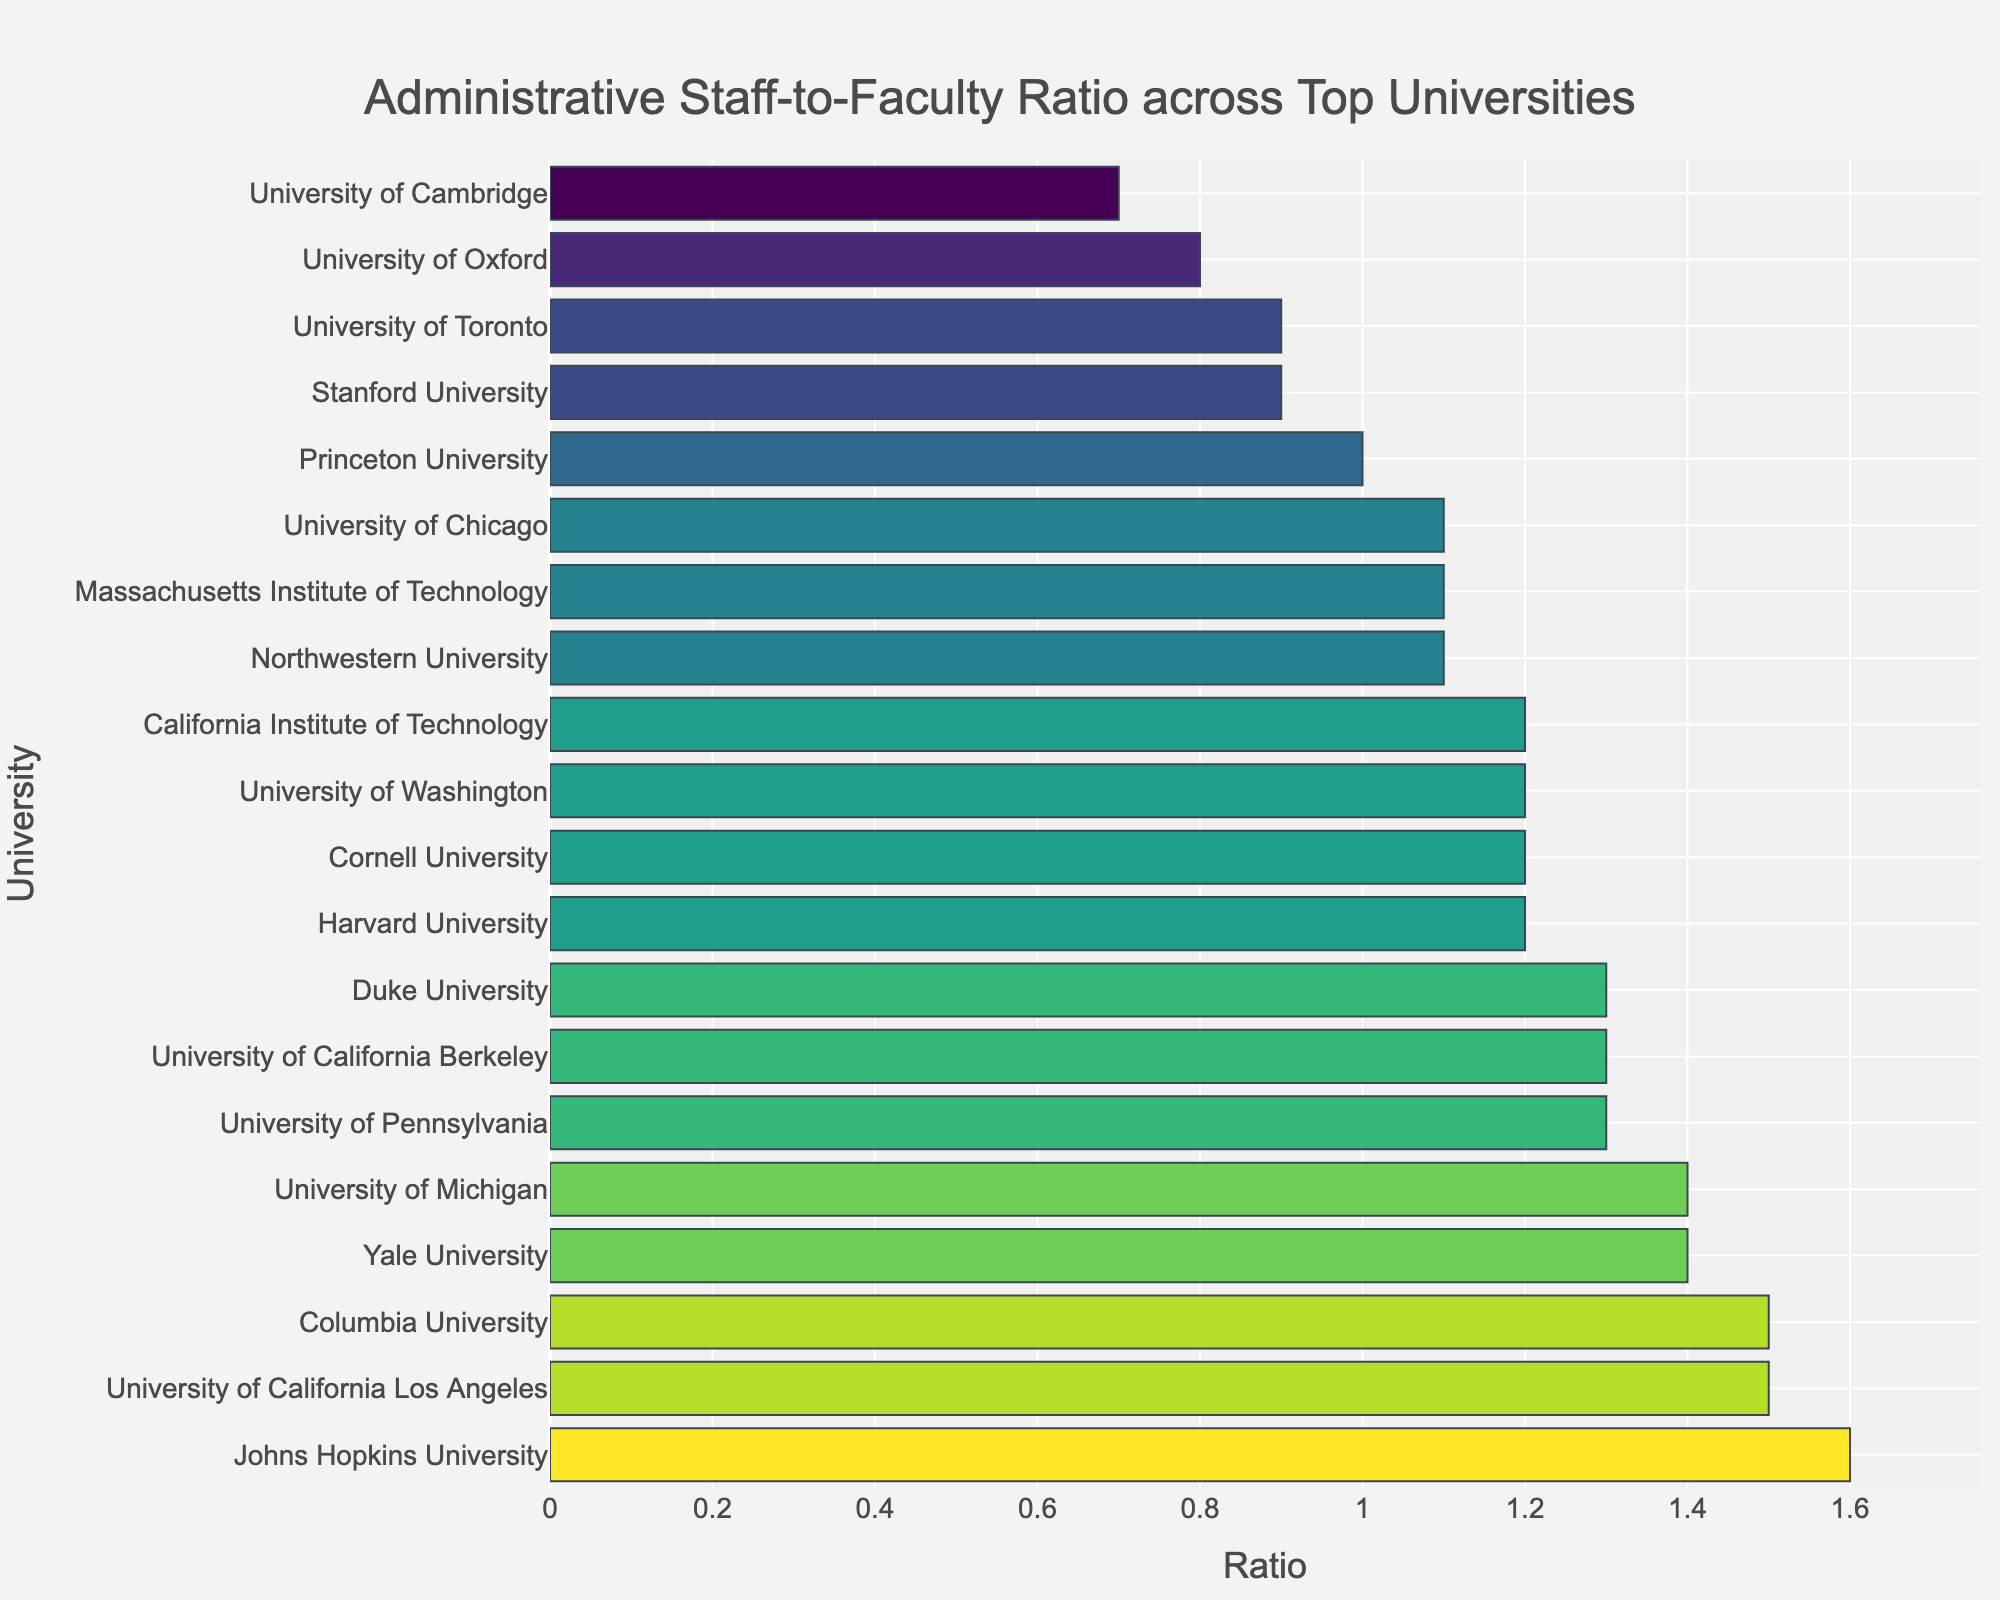What is the highest Administrative Staff-to-Faculty Ratio shown in the figure? The figure shows the Administrative Staff-to-Faculty Ratios of different universities. The highest ratio can be identified as the tallest bar.
Answer: 1.6 Which university has the lowest Administrative Staff-to-Faculty Ratio? The figure shows the ratios for different universities. The lowest ratio can be identified as the shortest bar. This is the University of Cambridge.
Answer: University of Cambridge How many universities have a ratio of 1.2? By counting the bars with the height equivalent to a ratio of 1.2 in the figure, we find three universities: Harvard University, California Institute of Technology, and University of Washington.
Answer: 3 Are there more universities with a ratio above 1.3 or below 1.0? Count the bars above the 1.3 line and below the 1.0 line. There are more universities above 1.3 (6) than below 1.0 (4).
Answer: Above 1.3 How does the Administrative Staff-to-Faculty Ratio of Yale University compare to Princeton University? Yale University has a ratio of 1.4, whereas Princeton University has a ratio of 1.0. Yale University's ratio is higher.
Answer: Yale > Princeton Which universities have exactly the same ratio? By visually inspecting the bars, we see that Northwestern University, Massachusetts Institute of Technology, University of Chicago, and Duke University each have a ratio of 1.1.
Answer: Northwestern University, Massachusetts Institute of Technology, University of Chicago, Duke University What is the average ratio of all universities listed? Sum all the ratios and divide by the number of universities. (1.2 + 0.9 + 1.1 + 1.3 + 0.8 + 0.7 + 1.4 + 1.0 + 1.2 + 1.5 + 1.1 + 1.3 + 1.2 + 1.4 + 1.6 + 1.3 + 1.1 + 1.5 + 0.9 + 1.2 = 24.2; 24.2 / 20 = 1.21)
Answer: 1.21 Which universities have a ratio higher than 1.5? The figure shows that Johns Hopkins University and Columbia University have ratios greater than 1.5.
Answer: Johns Hopkins University, Columbia University 